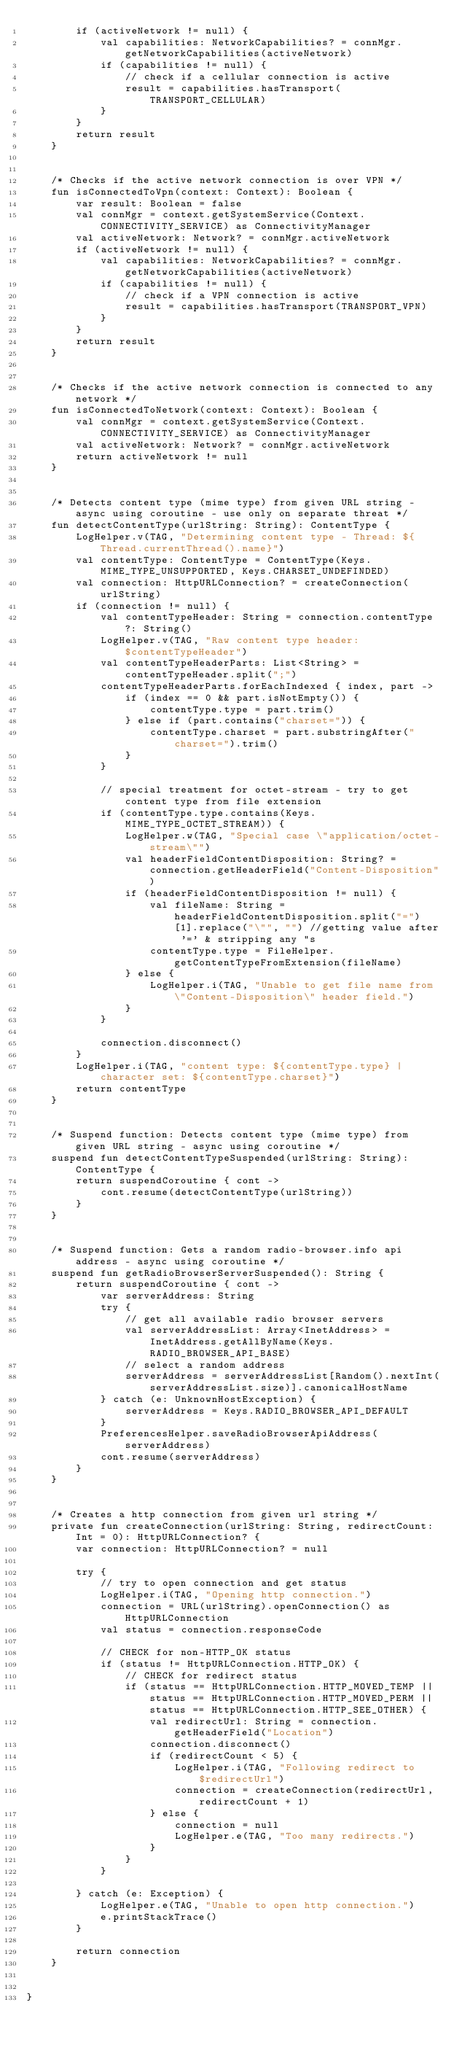Convert code to text. <code><loc_0><loc_0><loc_500><loc_500><_Kotlin_>        if (activeNetwork != null) {
            val capabilities: NetworkCapabilities? = connMgr.getNetworkCapabilities(activeNetwork)
            if (capabilities != null) {
                // check if a cellular connection is active
                result = capabilities.hasTransport(TRANSPORT_CELLULAR)
            }
        }
        return result
    }


    /* Checks if the active network connection is over VPN */
    fun isConnectedToVpn(context: Context): Boolean {
        var result: Boolean = false
        val connMgr = context.getSystemService(Context.CONNECTIVITY_SERVICE) as ConnectivityManager
        val activeNetwork: Network? = connMgr.activeNetwork
        if (activeNetwork != null) {
            val capabilities: NetworkCapabilities? = connMgr.getNetworkCapabilities(activeNetwork)
            if (capabilities != null) {
                // check if a VPN connection is active
                result = capabilities.hasTransport(TRANSPORT_VPN)
            }
        }
        return result
    }


    /* Checks if the active network connection is connected to any network */
    fun isConnectedToNetwork(context: Context): Boolean {
        val connMgr = context.getSystemService(Context.CONNECTIVITY_SERVICE) as ConnectivityManager
        val activeNetwork: Network? = connMgr.activeNetwork
        return activeNetwork != null
    }


    /* Detects content type (mime type) from given URL string - async using coroutine - use only on separate threat */
    fun detectContentType(urlString: String): ContentType {
        LogHelper.v(TAG, "Determining content type - Thread: ${Thread.currentThread().name}")
        val contentType: ContentType = ContentType(Keys.MIME_TYPE_UNSUPPORTED, Keys.CHARSET_UNDEFINDED)
        val connection: HttpURLConnection? = createConnection(urlString)
        if (connection != null) {
            val contentTypeHeader: String = connection.contentType ?: String()
            LogHelper.v(TAG, "Raw content type header: $contentTypeHeader")
            val contentTypeHeaderParts: List<String> = contentTypeHeader.split(";")
            contentTypeHeaderParts.forEachIndexed { index, part ->
                if (index == 0 && part.isNotEmpty()) {
                    contentType.type = part.trim()
                } else if (part.contains("charset=")) {
                    contentType.charset = part.substringAfter("charset=").trim()
                }
            }

            // special treatment for octet-stream - try to get content type from file extension
            if (contentType.type.contains(Keys.MIME_TYPE_OCTET_STREAM)) {
                LogHelper.w(TAG, "Special case \"application/octet-stream\"")
                val headerFieldContentDisposition: String? = connection.getHeaderField("Content-Disposition")
                if (headerFieldContentDisposition != null) {
                    val fileName: String = headerFieldContentDisposition.split("=")[1].replace("\"", "") //getting value after '=' & stripping any "s
                    contentType.type = FileHelper.getContentTypeFromExtension(fileName)
                } else {
                    LogHelper.i(TAG, "Unable to get file name from \"Content-Disposition\" header field.")
                }
            }

            connection.disconnect()
        }
        LogHelper.i(TAG, "content type: ${contentType.type} | character set: ${contentType.charset}")
        return contentType
    }


    /* Suspend function: Detects content type (mime type) from given URL string - async using coroutine */
    suspend fun detectContentTypeSuspended(urlString: String): ContentType {
        return suspendCoroutine { cont ->
            cont.resume(detectContentType(urlString))
        }
    }


    /* Suspend function: Gets a random radio-browser.info api address - async using coroutine */
    suspend fun getRadioBrowserServerSuspended(): String {
        return suspendCoroutine { cont ->
            var serverAddress: String
            try {
                // get all available radio browser servers
                val serverAddressList: Array<InetAddress> = InetAddress.getAllByName(Keys.RADIO_BROWSER_API_BASE)
                // select a random address
                serverAddress = serverAddressList[Random().nextInt(serverAddressList.size)].canonicalHostName
            } catch (e: UnknownHostException) {
                serverAddress = Keys.RADIO_BROWSER_API_DEFAULT
            }
            PreferencesHelper.saveRadioBrowserApiAddress(serverAddress)
            cont.resume(serverAddress)
        }
    }


    /* Creates a http connection from given url string */
    private fun createConnection(urlString: String, redirectCount: Int = 0): HttpURLConnection? {
        var connection: HttpURLConnection? = null

        try {
            // try to open connection and get status
            LogHelper.i(TAG, "Opening http connection.")
            connection = URL(urlString).openConnection() as HttpURLConnection
            val status = connection.responseCode

            // CHECK for non-HTTP_OK status
            if (status != HttpURLConnection.HTTP_OK) {
                // CHECK for redirect status
                if (status == HttpURLConnection.HTTP_MOVED_TEMP || status == HttpURLConnection.HTTP_MOVED_PERM || status == HttpURLConnection.HTTP_SEE_OTHER) {
                    val redirectUrl: String = connection.getHeaderField("Location")
                    connection.disconnect()
                    if (redirectCount < 5) {
                        LogHelper.i(TAG, "Following redirect to $redirectUrl")
                        connection = createConnection(redirectUrl, redirectCount + 1)
                    } else {
                        connection = null
                        LogHelper.e(TAG, "Too many redirects.")
                    }
                }
            }

        } catch (e: Exception) {
            LogHelper.e(TAG, "Unable to open http connection.")
            e.printStackTrace()
        }

        return connection
    }


}
</code> 